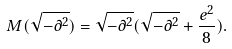Convert formula to latex. <formula><loc_0><loc_0><loc_500><loc_500>M ( \sqrt { - \partial ^ { 2 } } ) = \sqrt { - \partial ^ { 2 } } ( \sqrt { - \partial ^ { 2 } } + \frac { e ^ { 2 } } { 8 } ) .</formula> 